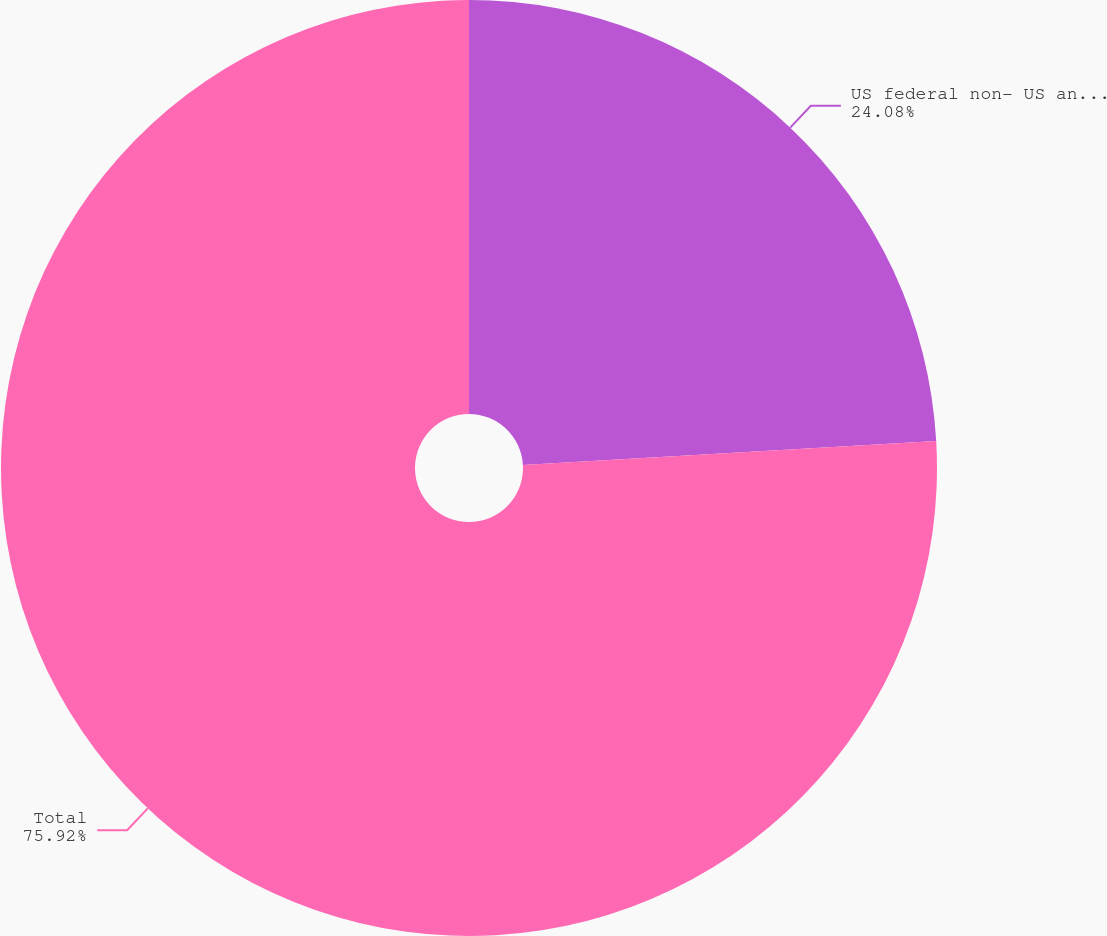<chart> <loc_0><loc_0><loc_500><loc_500><pie_chart><fcel>US federal non- US and state<fcel>Total<nl><fcel>24.08%<fcel>75.92%<nl></chart> 